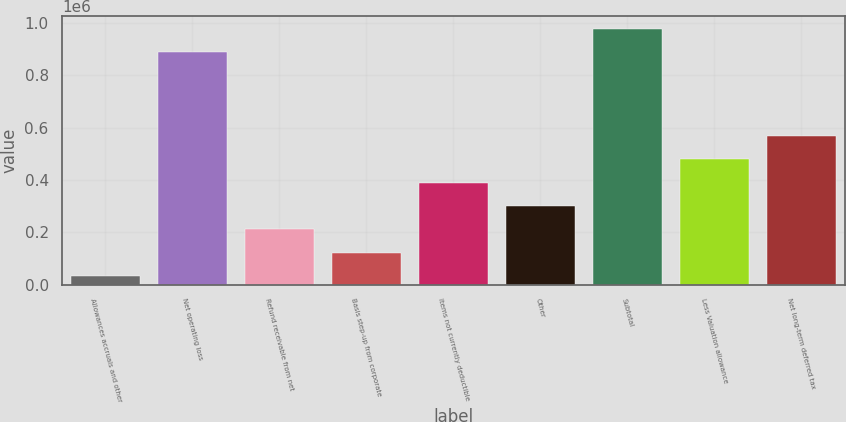Convert chart to OTSL. <chart><loc_0><loc_0><loc_500><loc_500><bar_chart><fcel>Allowances accruals and other<fcel>Net operating loss<fcel>Refund receivable from net<fcel>Basis step-up from corporate<fcel>Items not currently deductible<fcel>Other<fcel>Subtotal<fcel>Less Valuation allowance<fcel>Net long-term deferred tax<nl><fcel>31359<fcel>888826<fcel>210496<fcel>120928<fcel>389634<fcel>300065<fcel>978395<fcel>479202<fcel>568771<nl></chart> 